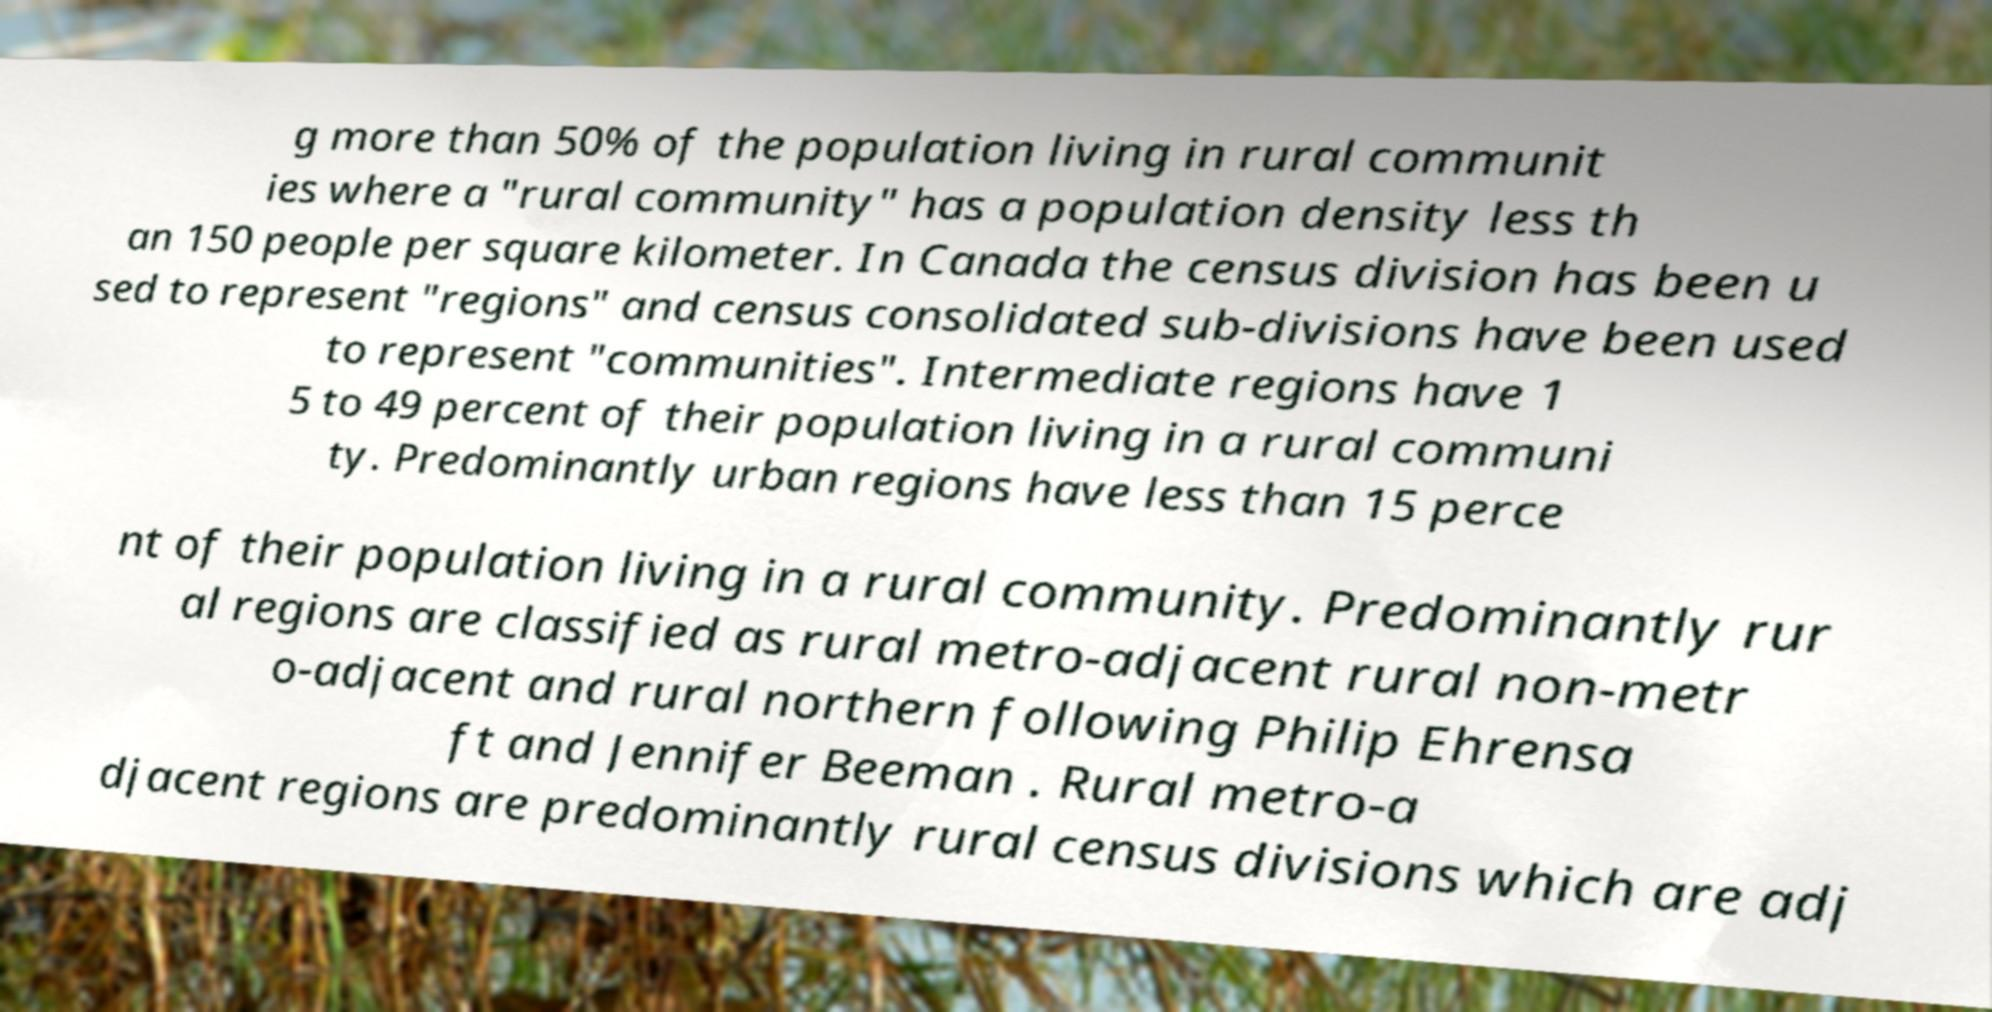There's text embedded in this image that I need extracted. Can you transcribe it verbatim? g more than 50% of the population living in rural communit ies where a "rural community" has a population density less th an 150 people per square kilometer. In Canada the census division has been u sed to represent "regions" and census consolidated sub-divisions have been used to represent "communities". Intermediate regions have 1 5 to 49 percent of their population living in a rural communi ty. Predominantly urban regions have less than 15 perce nt of their population living in a rural community. Predominantly rur al regions are classified as rural metro-adjacent rural non-metr o-adjacent and rural northern following Philip Ehrensa ft and Jennifer Beeman . Rural metro-a djacent regions are predominantly rural census divisions which are adj 